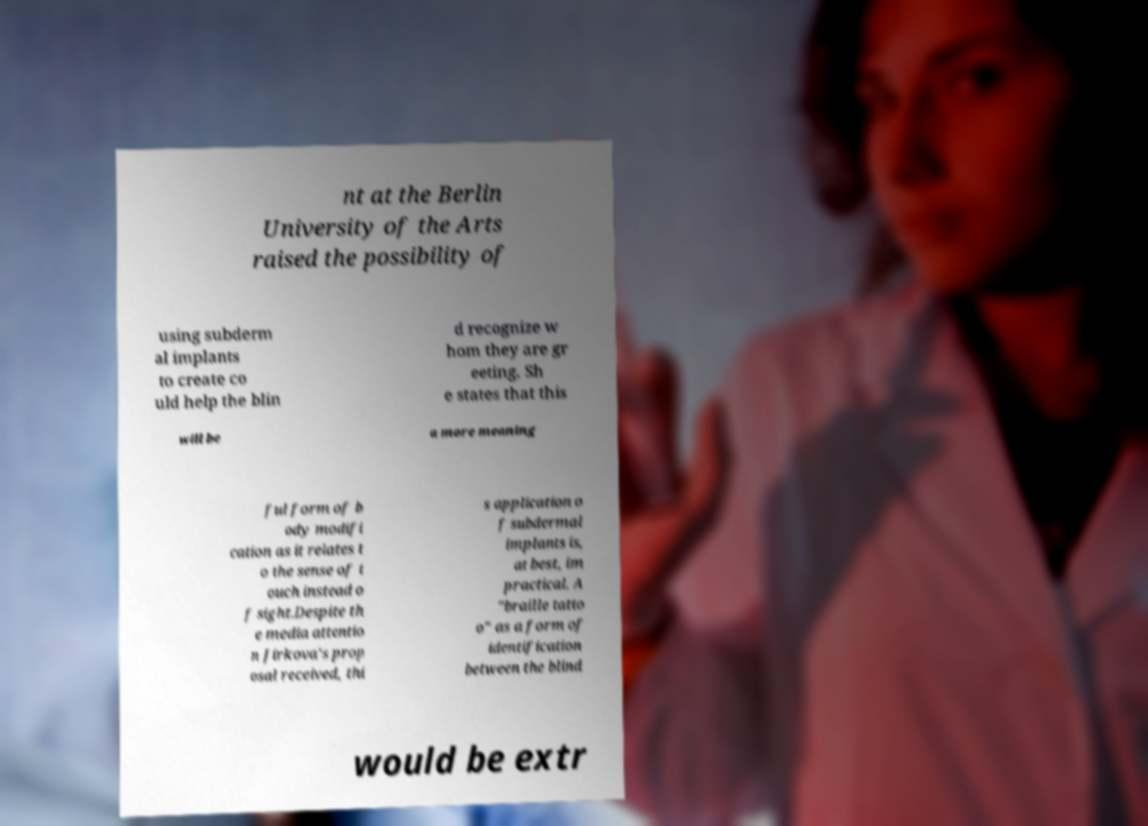Could you assist in decoding the text presented in this image and type it out clearly? nt at the Berlin University of the Arts raised the possibility of using subderm al implants to create co uld help the blin d recognize w hom they are gr eeting. Sh e states that this will be a more meaning ful form of b ody modifi cation as it relates t o the sense of t ouch instead o f sight.Despite th e media attentio n Jirkova's prop osal received, thi s application o f subdermal implants is, at best, im practical. A "braille tatto o" as a form of identification between the blind would be extr 